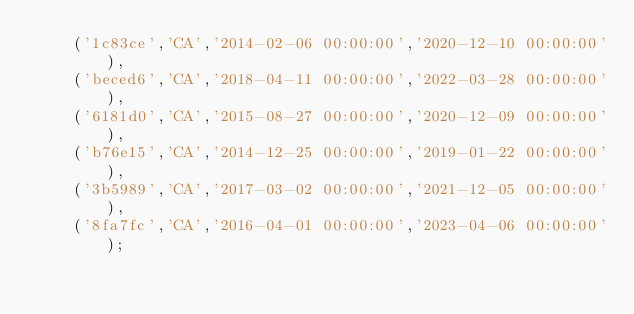<code> <loc_0><loc_0><loc_500><loc_500><_SQL_>    ('1c83ce','CA','2014-02-06 00:00:00','2020-12-10 00:00:00'),
    ('beced6','CA','2018-04-11 00:00:00','2022-03-28 00:00:00'),
    ('6181d0','CA','2015-08-27 00:00:00','2020-12-09 00:00:00'),
    ('b76e15','CA','2014-12-25 00:00:00','2019-01-22 00:00:00'),
    ('3b5989','CA','2017-03-02 00:00:00','2021-12-05 00:00:00'),
    ('8fa7fc','CA','2016-04-01 00:00:00','2023-04-06 00:00:00');
</code> 